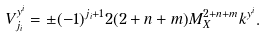Convert formula to latex. <formula><loc_0><loc_0><loc_500><loc_500>V ^ { y ^ { i } } _ { j _ { i } } = \pm ( - 1 ) ^ { j _ { i } + 1 } 2 ( 2 + n + m ) M _ { X } ^ { 2 + n + m } k ^ { y ^ { i } } . \,</formula> 